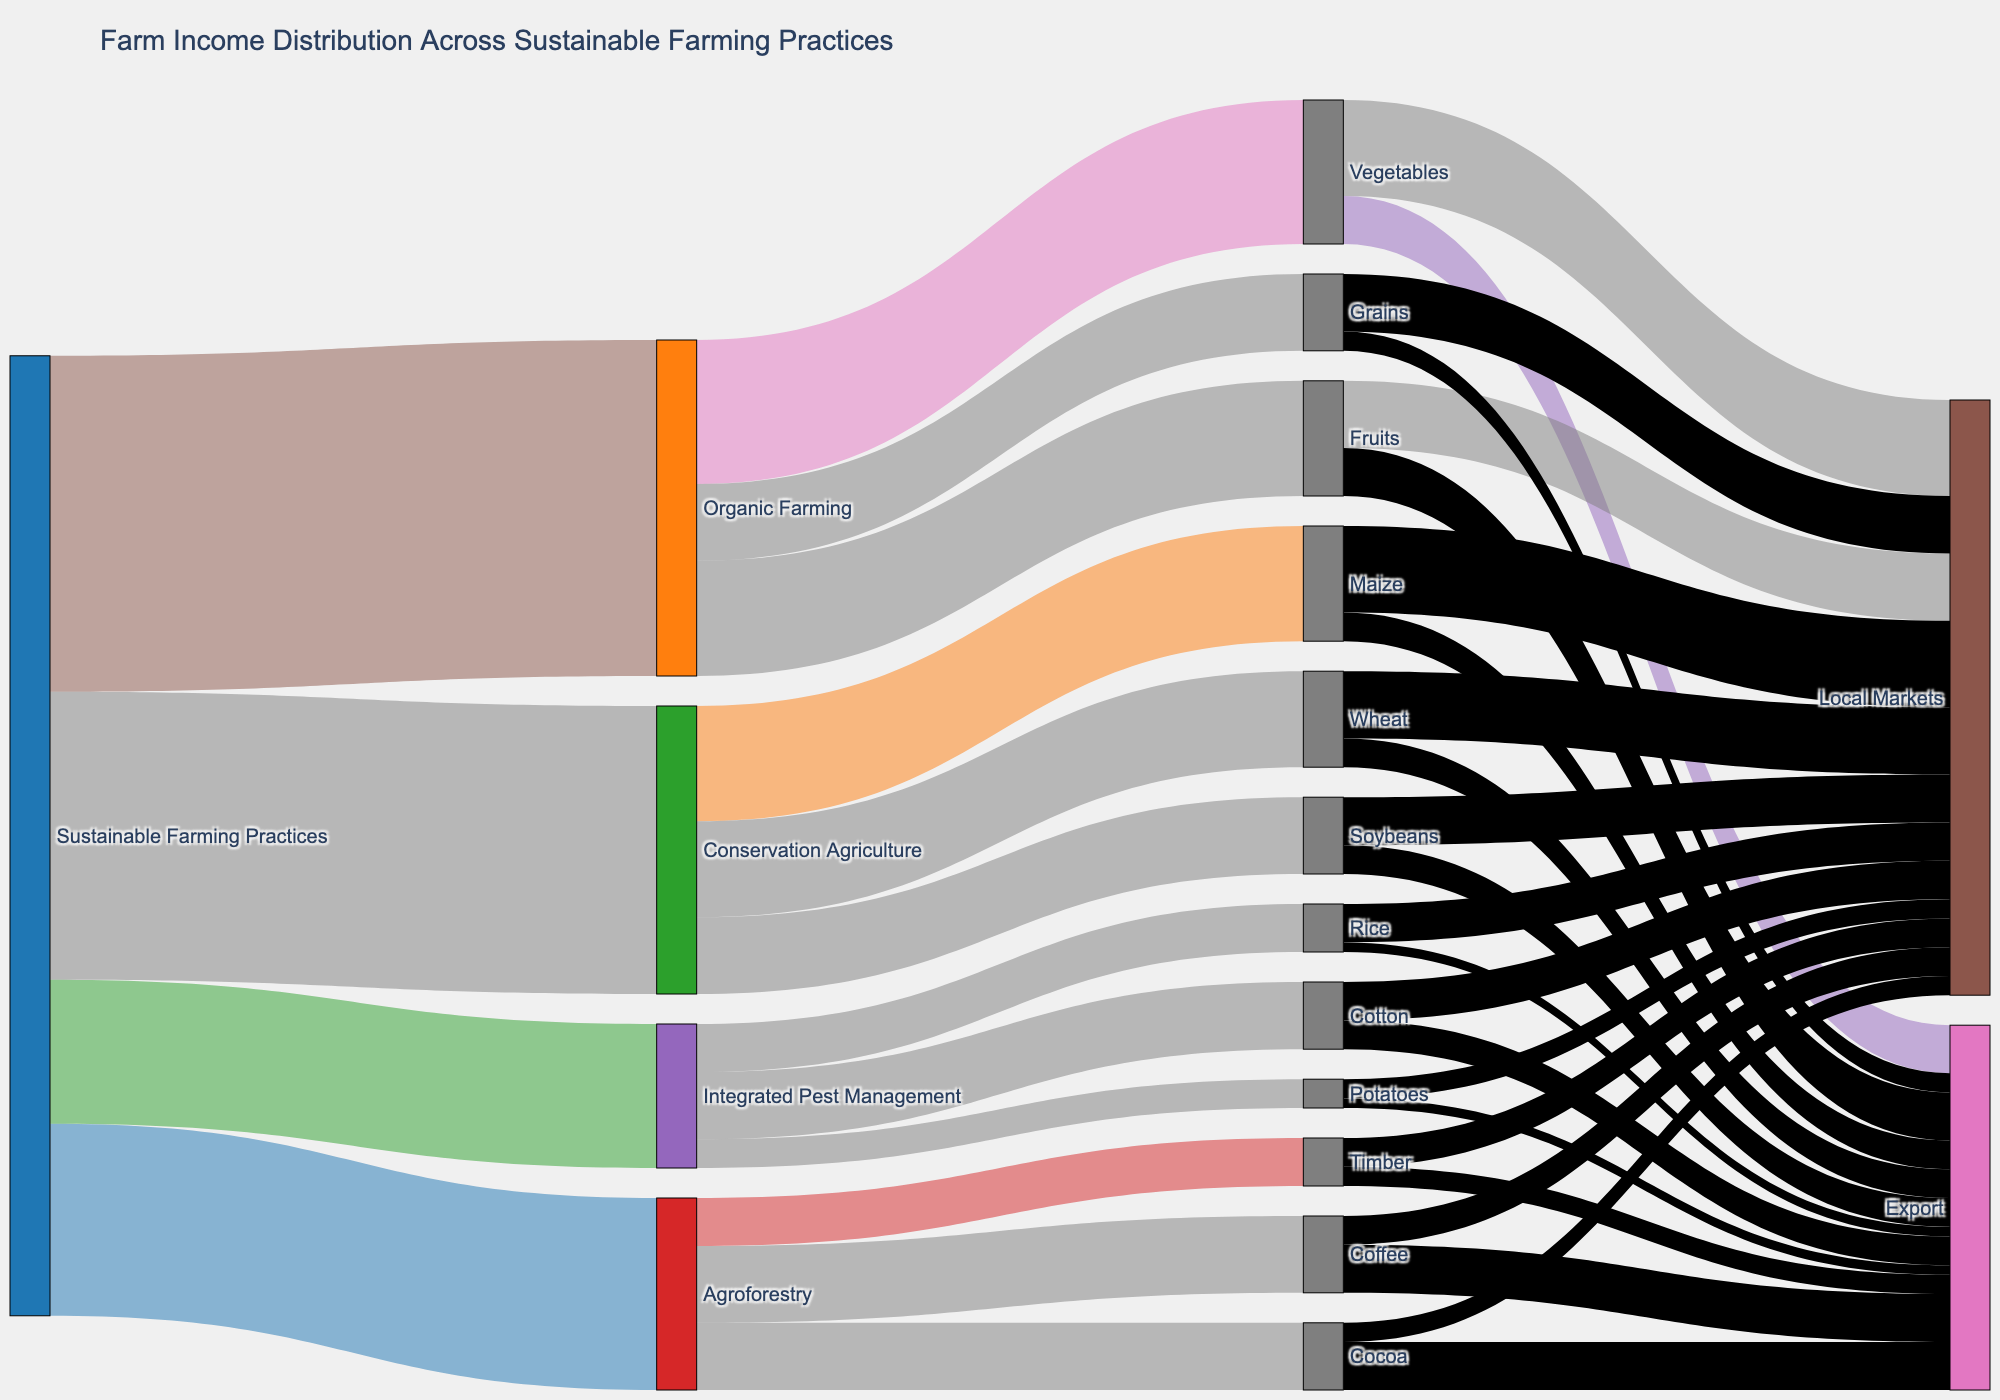What is the title of the Sankey diagram? The title of the diagram is typically displayed at the top of the figure. In this case, the title is clearly stated as "Farm Income Distribution Across Sustainable Farming Practices."
Answer: Farm Income Distribution Across Sustainable Farming Practices Which sustainable farming practice has the highest allocation of income? By observing the width of the flows from "Sustainable Farming Practices" to the first tier targets, the widest flow goes to "Organic Farming," indicating the highest allocation of income.
Answer: Organic Farming How is income distributed among the categories within Organic Farming? Each flow from "Organic Farming" to its subcategories shows the distribution, with the values listed as: Vegetables (15), Fruits (12), and Grains (8). Adding these values confirms the total.
Answer: Vegetables: 15, Fruits: 12, Grains: 8 What is the total combined income from "Agroforestry"? Summing up the values of the outgoing links from "Agroforestry" to its subcategories: Coffee (8), Cocoa (7), and Timber (5). Mathematically, 8 + 7 + 5 = 20.
Answer: 20 Which practice contributes more to local markets: Vegetables under Organic Farming or Maize under Conservation Agriculture? First, note the values directed to local markets: Vegetables (10), Maize (9). Comparison shows that Vegetables contribute more.
Answer: Vegetables What is the total income from "Local Markets"? Sum all income values directed towards "Local Markets": Vegetables (10), Fruits (7), Grains (6), Maize (9), Wheat (7), Soybeans (5), Coffee (3), Cocoa (2), Timber (3), Cotton (4), Rice (4), Potatoes (2). Adding these values: 10+7+6+9+7+5+3+2+3+4+4+2 = 62.
Answer: 62 How does the income from "Export" compare between "Cocoa" and "Rice"? By looking at the links directing income to Export: Cocoa (5), Rice (1). Cocoa has a higher value than Rice for exports.
Answer: Cocoa What proportion of total income from "Integrated Pest Management" comes from "Cotton"? Out of the total for Integrated Pest Management (15), Cotton provides 7. The proportion is calculated as 7/15 = 0.4667 (approximately 46.67%).
Answer: 46.67% What are the nodes directly connected to "Conservation Agriculture"? Directly trace the lines from Conservation Agriculture to find its nodes: Maize, Wheat, Soybeans.
Answer: Maize, Wheat, Soybeans Is the total allocation to "Export" higher for Agricultural Products from "Conservation Agriculture" or "Agroforestry"? Summing up Export allocations for Conservation Agriculture's products: Maize (3), Wheat (3), Soybeans (3) gives a total of 9. For Agroforestry: Coffee (5), Cocoa (5), Timber (2) sums to 12. Comparatively, Agroforestry's total is higher.
Answer: Agroforestry 